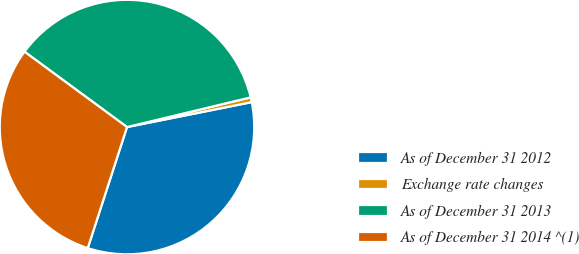<chart> <loc_0><loc_0><loc_500><loc_500><pie_chart><fcel>As of December 31 2012<fcel>Exchange rate changes<fcel>As of December 31 2013<fcel>As of December 31 2014 ^(1)<nl><fcel>33.13%<fcel>0.61%<fcel>36.16%<fcel>30.1%<nl></chart> 